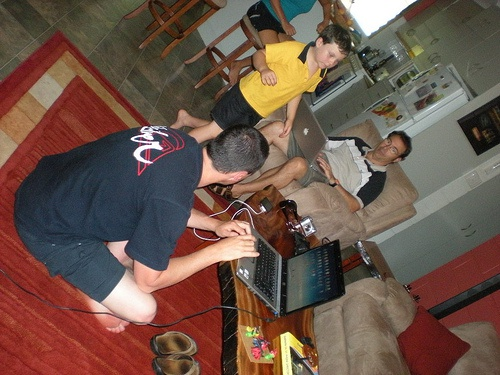Describe the objects in this image and their specific colors. I can see people in black, darkblue, and gray tones, people in black, gold, and tan tones, couch in black, gray, and maroon tones, people in black, darkgray, and gray tones, and chair in black, gray, and tan tones in this image. 